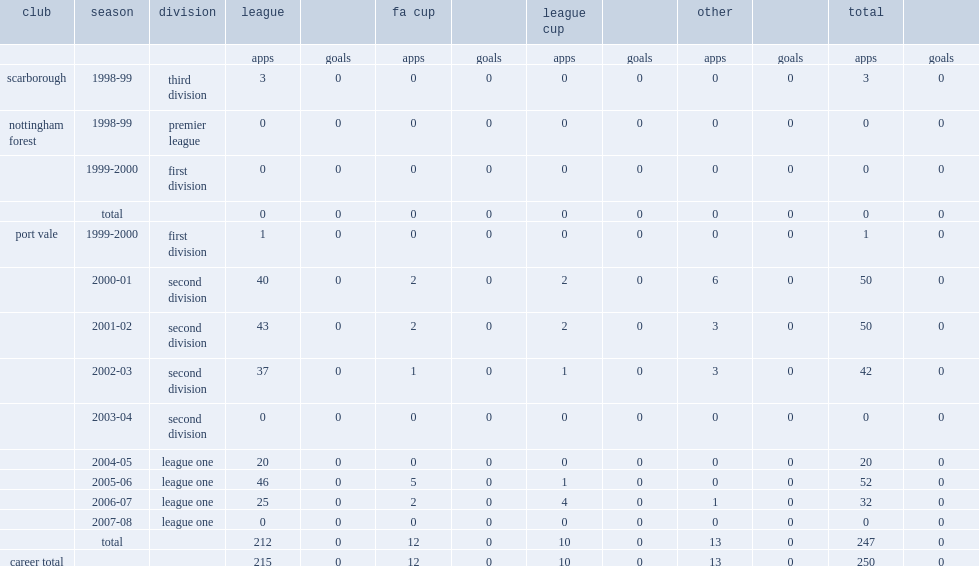Which club did goodlad join and not make an appearance during the premier league in 1998-99? Nottingham forest. 